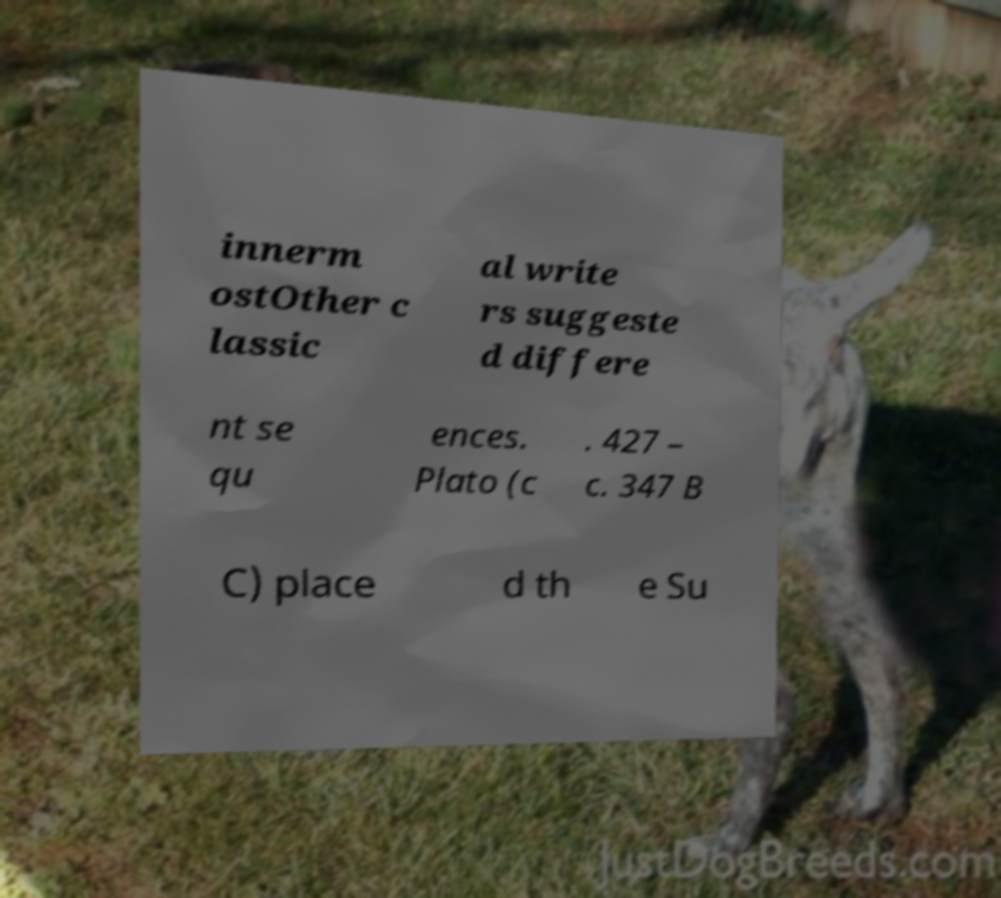Please read and relay the text visible in this image. What does it say? innerm ostOther c lassic al write rs suggeste d differe nt se qu ences. Plato (c . 427 – c. 347 B C) place d th e Su 